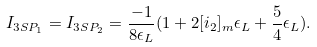<formula> <loc_0><loc_0><loc_500><loc_500>I _ { 3 S P _ { 1 } } = I _ { 3 S P _ { 2 } } = \frac { - 1 } { 8 \epsilon _ { L } } ( 1 + 2 [ i _ { 2 } ] _ { m } \epsilon _ { L } + \frac { 5 } { 4 } \epsilon _ { L } ) .</formula> 